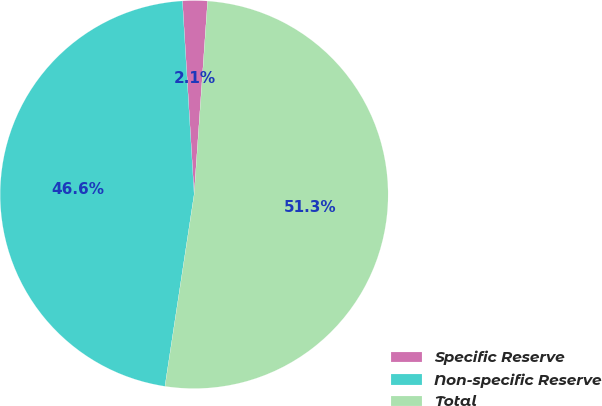Convert chart. <chart><loc_0><loc_0><loc_500><loc_500><pie_chart><fcel>Specific Reserve<fcel>Non-specific Reserve<fcel>Total<nl><fcel>2.07%<fcel>46.63%<fcel>51.29%<nl></chart> 